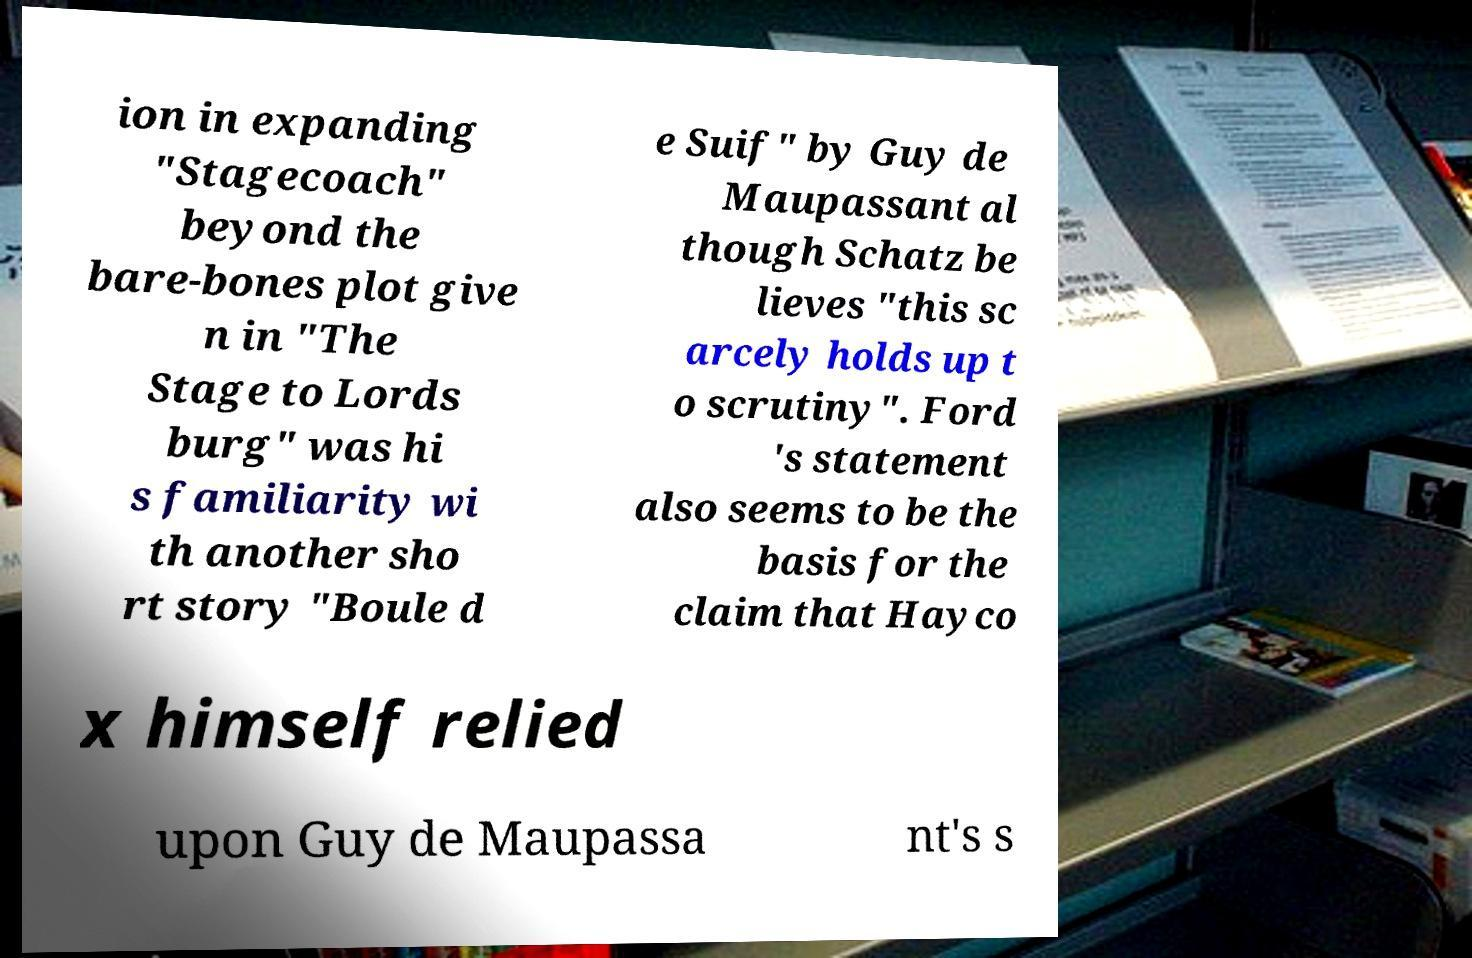Can you read and provide the text displayed in the image?This photo seems to have some interesting text. Can you extract and type it out for me? ion in expanding "Stagecoach" beyond the bare-bones plot give n in "The Stage to Lords burg" was hi s familiarity wi th another sho rt story "Boule d e Suif" by Guy de Maupassant al though Schatz be lieves "this sc arcely holds up t o scrutiny". Ford 's statement also seems to be the basis for the claim that Hayco x himself relied upon Guy de Maupassa nt's s 